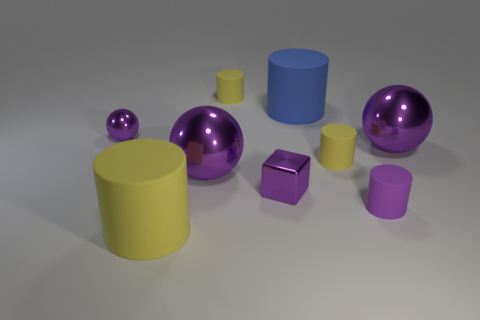What is the material of the cylinder that is the same color as the small sphere?
Provide a short and direct response. Rubber. Does the tiny block have the same color as the tiny metallic ball?
Provide a succinct answer. Yes. What is the size of the sphere to the right of the tiny metallic cube?
Provide a succinct answer. Large. Is there anything else that is the same color as the small ball?
Your answer should be very brief. Yes. There is a tiny rubber object that is behind the blue thing; what color is it?
Provide a succinct answer. Yellow. There is a large metal ball that is to the right of the small purple rubber thing; is it the same color as the metal block?
Give a very brief answer. Yes. What material is the small purple thing that is the same shape as the blue thing?
Your answer should be compact. Rubber. What number of blue matte cylinders are the same size as the purple rubber object?
Offer a terse response. 0. The large yellow thing has what shape?
Provide a succinct answer. Cylinder. What size is the matte thing that is right of the blue cylinder and on the left side of the purple rubber thing?
Your answer should be very brief. Small. 